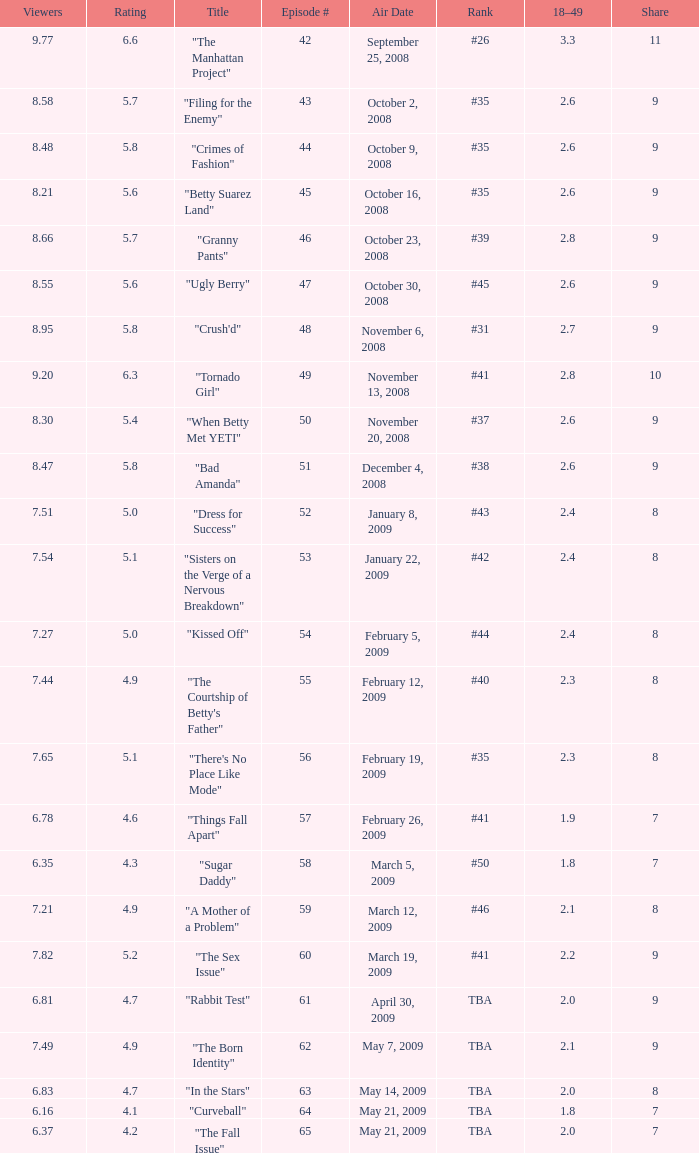What is the lowest Viewers that has an Episode #higher than 58 with a title of "curveball" less than 4.1 rating? None. 